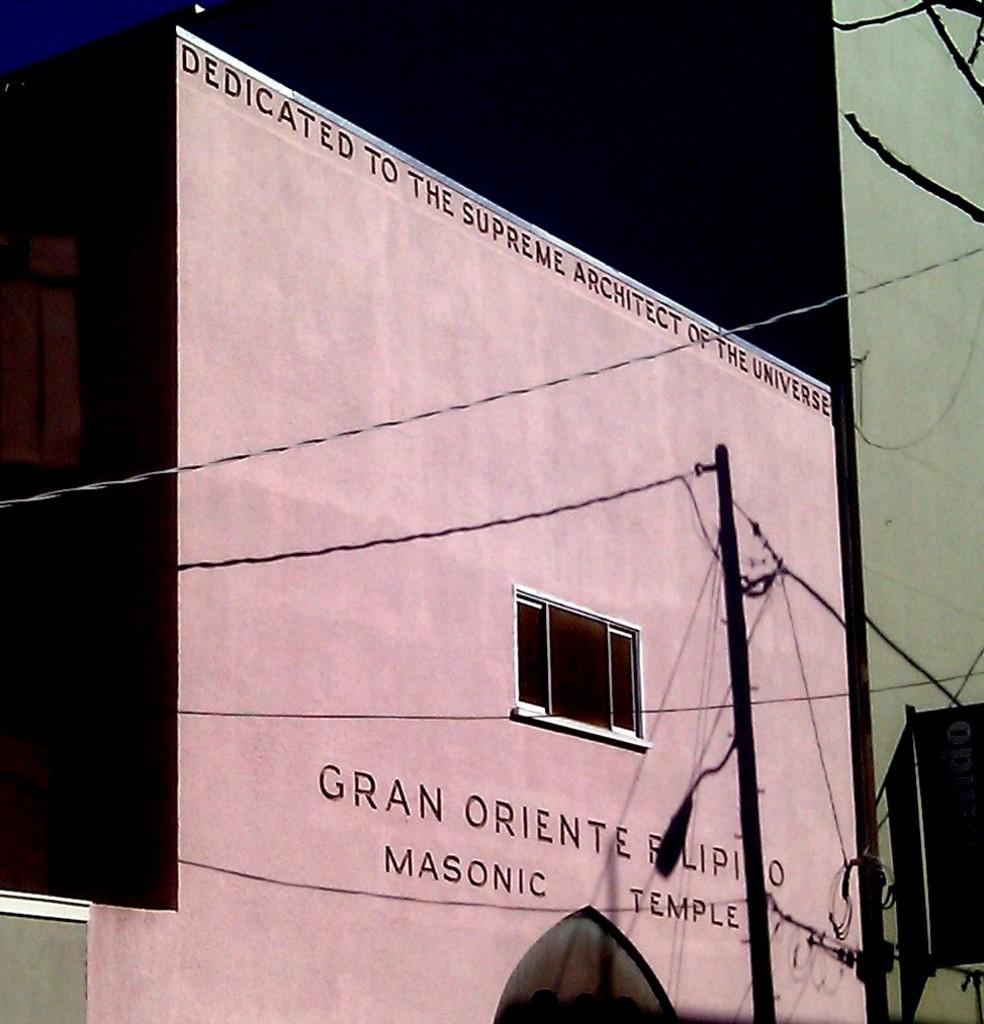What type of structure is present in the picture? There is a building in the picture. What feature can be seen on the building? The building has a window. Is there any text or image on the building? Yes, there is something written on the building. What else can be seen in the picture besides the building? There is a pole and wires in the picture. How would you describe the style of the image? The image is a cartoon. How many tigers are visible in the picture? There are no tigers present in the picture. What type of approval is required for the building in the image? The image does not provide information about any required approvals for the building. 